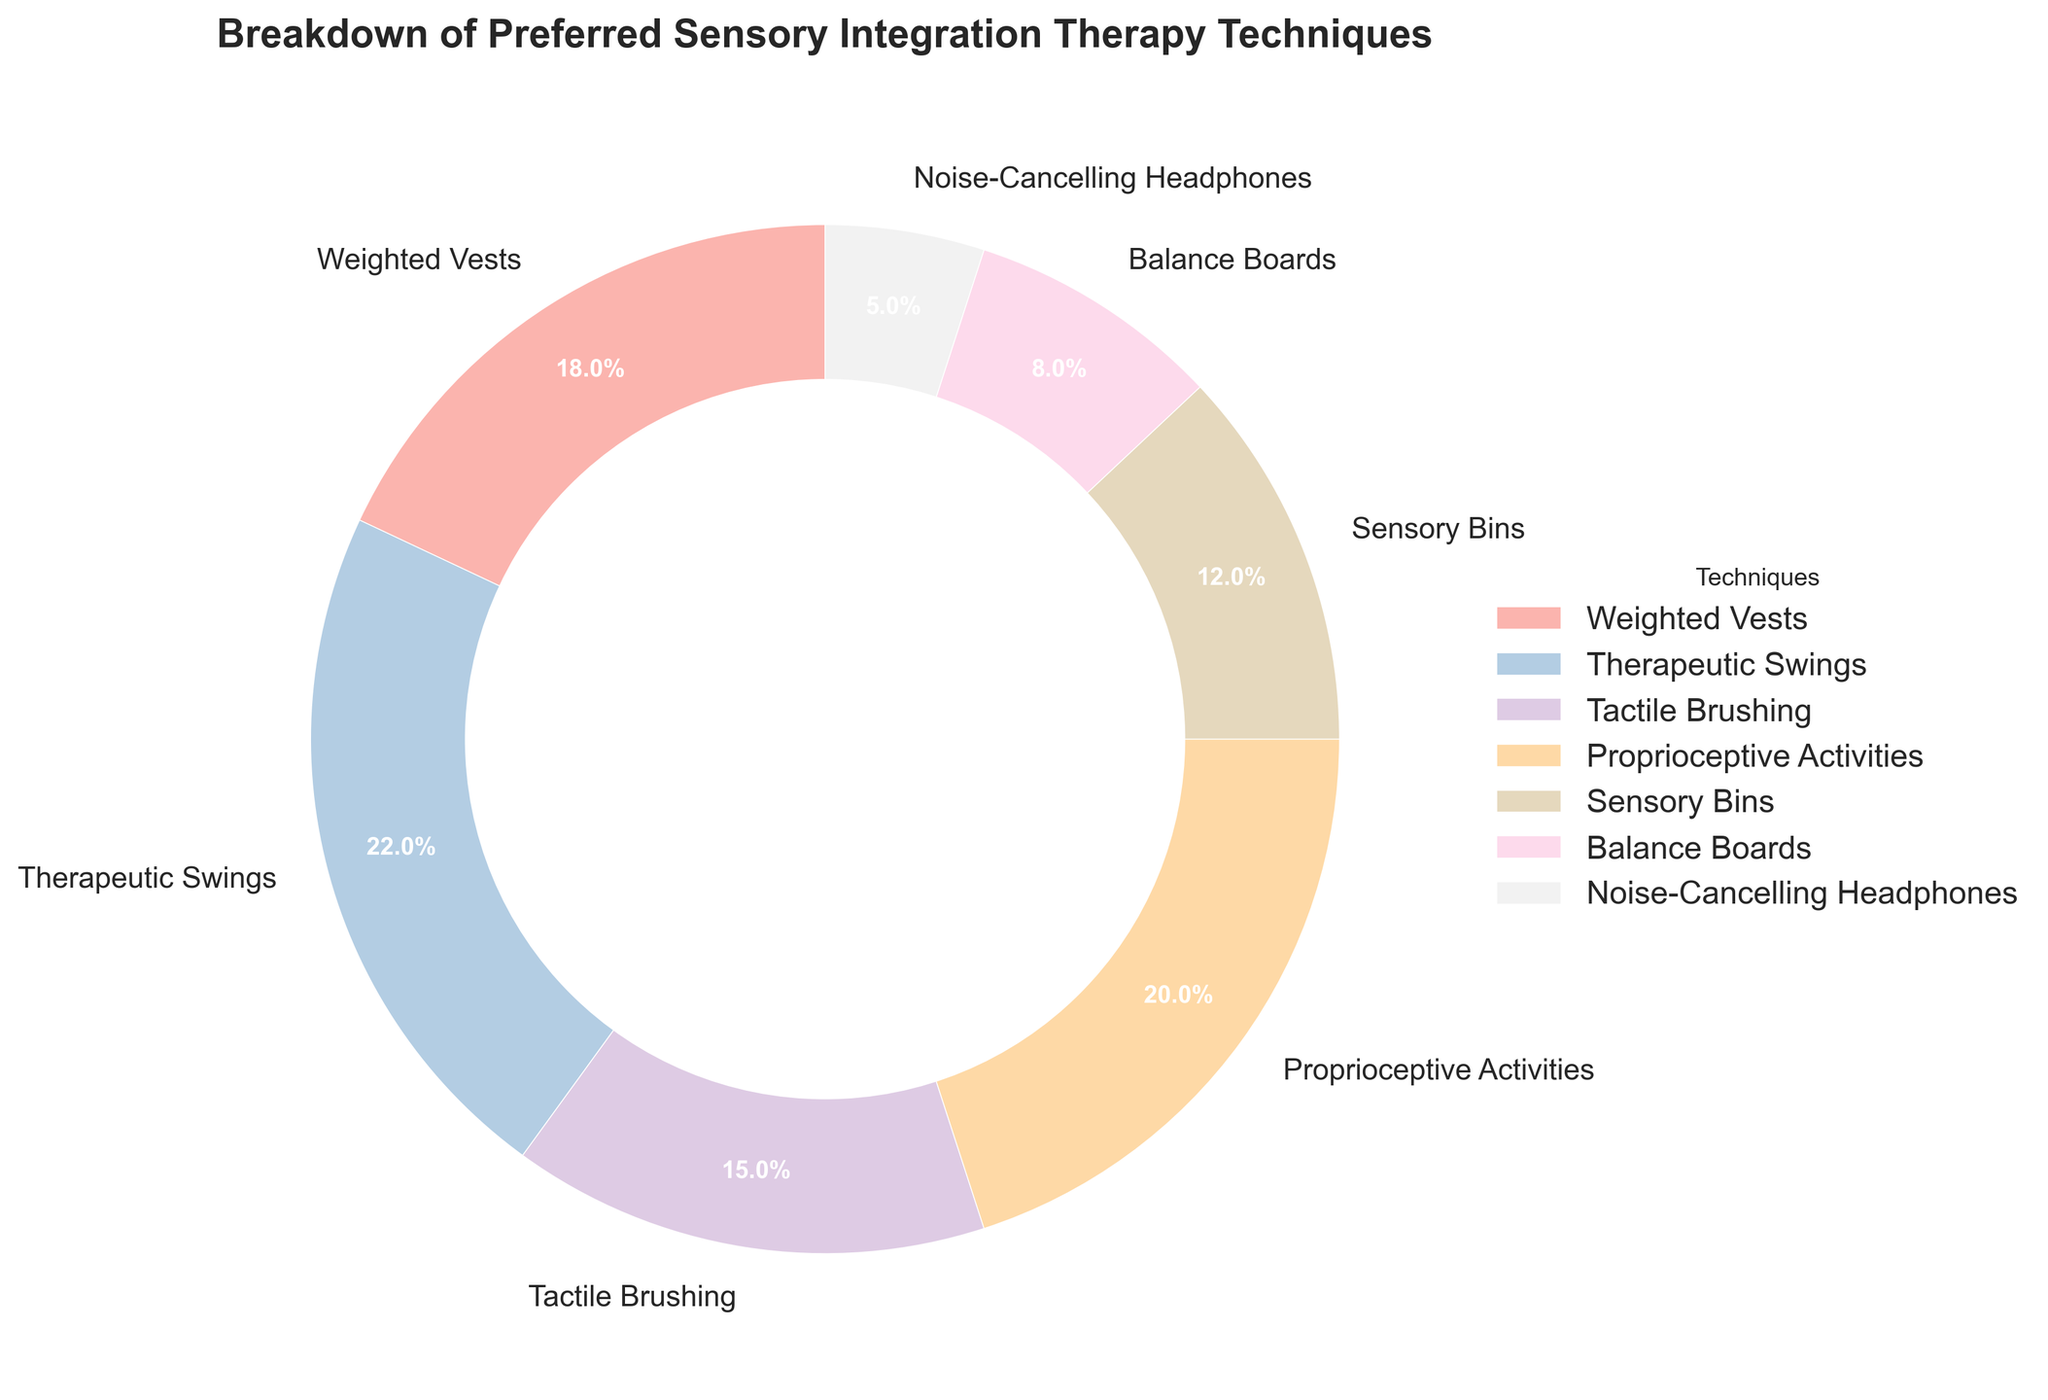What percentage of the preferred sensory integration therapy techniques do Proprietive Activities and Sensory Bins together account for? Add the percentages for Proprioceptive Activities (20%) and Sensory Bins (12%): 20 + 12 = 32
Answer: 32% Which therapy technique has a higher percentage, Weighted Vests or Tactile Brushing? Compare the percentages of the two techniques: Weighted Vests (18%) is higher than Tactile Brushing (15%).
Answer: Weighted Vests What is the least preferred sensory integration therapy technique shown in the chart? The figure shows that Noise-Cancelling Headphones has the lowest percentage (5%).
Answer: Noise-Cancelling Headphones How many techniques individually accounted for 20% or more of the preferences? Identify the techniques that account for 20% or more: Therapeutic Swings (22%) and Proprioceptive Activities (20%). There are 2 such techniques.
Answer: 2 techniques Which color is used to represent Therapeutic Swings in the pie chart? Refer to the legend and pie chart to see the color corresponding to Therapeutic Swings.
Answer: (Assuming Therapeutic Swings is represented by pink based on Pastel1 colormap) If we combine the percentages of Sensory Bins, Balance Boards, and Noise-Cancelling Headphones, what is their total percentage? Add the percentages of Sensory Bins (12%), Balance Boards (8%), and Noise-Cancelling Headphones (5%): 12 + 8 + 5 = 25
Answer: 25% Is the sum of the percentages of Therapeutic Swings and Tactile Brushing greater than the sum of Weighted Vests and Balance Boards? Calculate both sums: Therapeutic Swings (22%) + Tactile Brushing (15%) = 37%; Weighted Vests (18%) + Balance Boards (8%) = 26%. Compare 37% and 26%.
Answer: Yes Which technique is represented by the largest wedge in the pie chart? The largest wedge corresponds to the highest percentage, which is Therapeutic Swings (22%).
Answer: Therapeutic Swings 